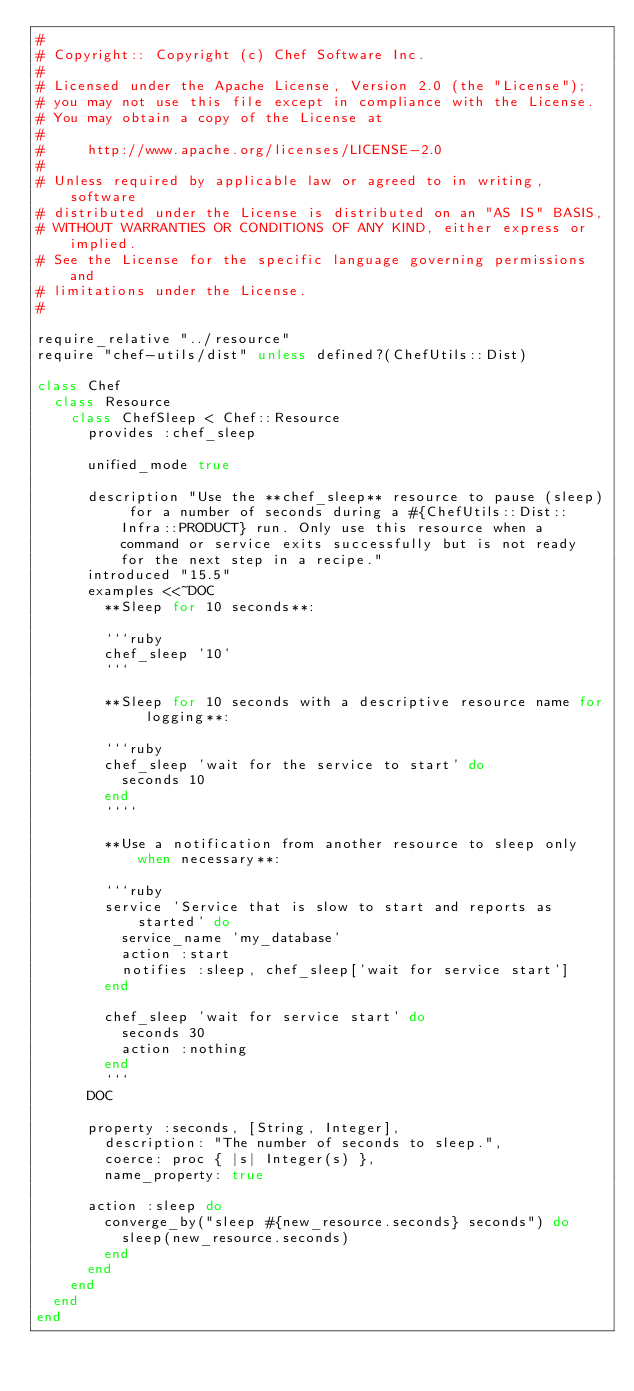<code> <loc_0><loc_0><loc_500><loc_500><_Ruby_>#
# Copyright:: Copyright (c) Chef Software Inc.
#
# Licensed under the Apache License, Version 2.0 (the "License");
# you may not use this file except in compliance with the License.
# You may obtain a copy of the License at
#
#     http://www.apache.org/licenses/LICENSE-2.0
#
# Unless required by applicable law or agreed to in writing, software
# distributed under the License is distributed on an "AS IS" BASIS,
# WITHOUT WARRANTIES OR CONDITIONS OF ANY KIND, either express or implied.
# See the License for the specific language governing permissions and
# limitations under the License.
#

require_relative "../resource"
require "chef-utils/dist" unless defined?(ChefUtils::Dist)

class Chef
  class Resource
    class ChefSleep < Chef::Resource
      provides :chef_sleep

      unified_mode true

      description "Use the **chef_sleep** resource to pause (sleep) for a number of seconds during a #{ChefUtils::Dist::Infra::PRODUCT} run. Only use this resource when a command or service exits successfully but is not ready for the next step in a recipe."
      introduced "15.5"
      examples <<~DOC
        **Sleep for 10 seconds**:

        ```ruby
        chef_sleep '10'
        ```

        **Sleep for 10 seconds with a descriptive resource name for logging**:

        ```ruby
        chef_sleep 'wait for the service to start' do
          seconds 10
        end
        ````

        **Use a notification from another resource to sleep only when necessary**:

        ```ruby
        service 'Service that is slow to start and reports as started' do
          service_name 'my_database'
          action :start
          notifies :sleep, chef_sleep['wait for service start']
        end

        chef_sleep 'wait for service start' do
          seconds 30
          action :nothing
        end
        ```
      DOC

      property :seconds, [String, Integer],
        description: "The number of seconds to sleep.",
        coerce: proc { |s| Integer(s) },
        name_property: true

      action :sleep do
        converge_by("sleep #{new_resource.seconds} seconds") do
          sleep(new_resource.seconds)
        end
      end
    end
  end
end
</code> 